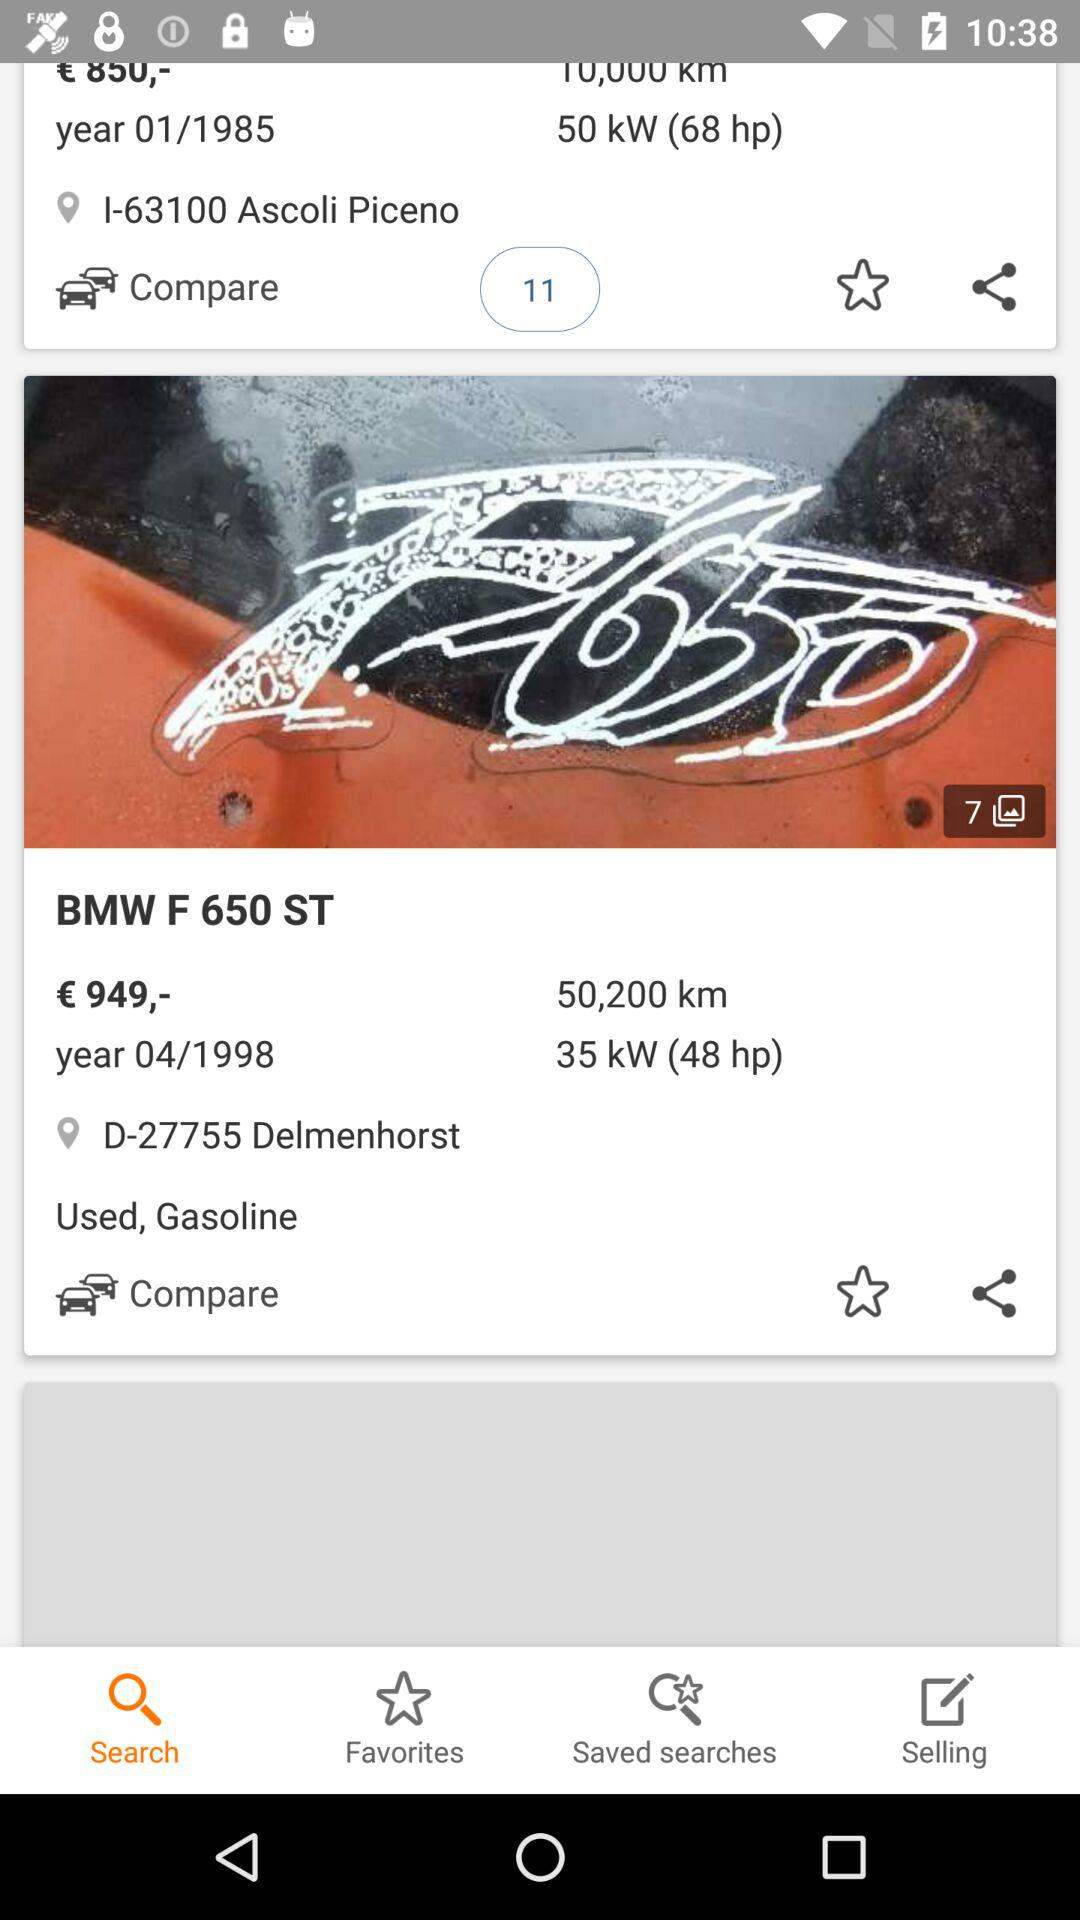What is the location of the owner? The location of the owner is D-27755 Delmenhorst. 